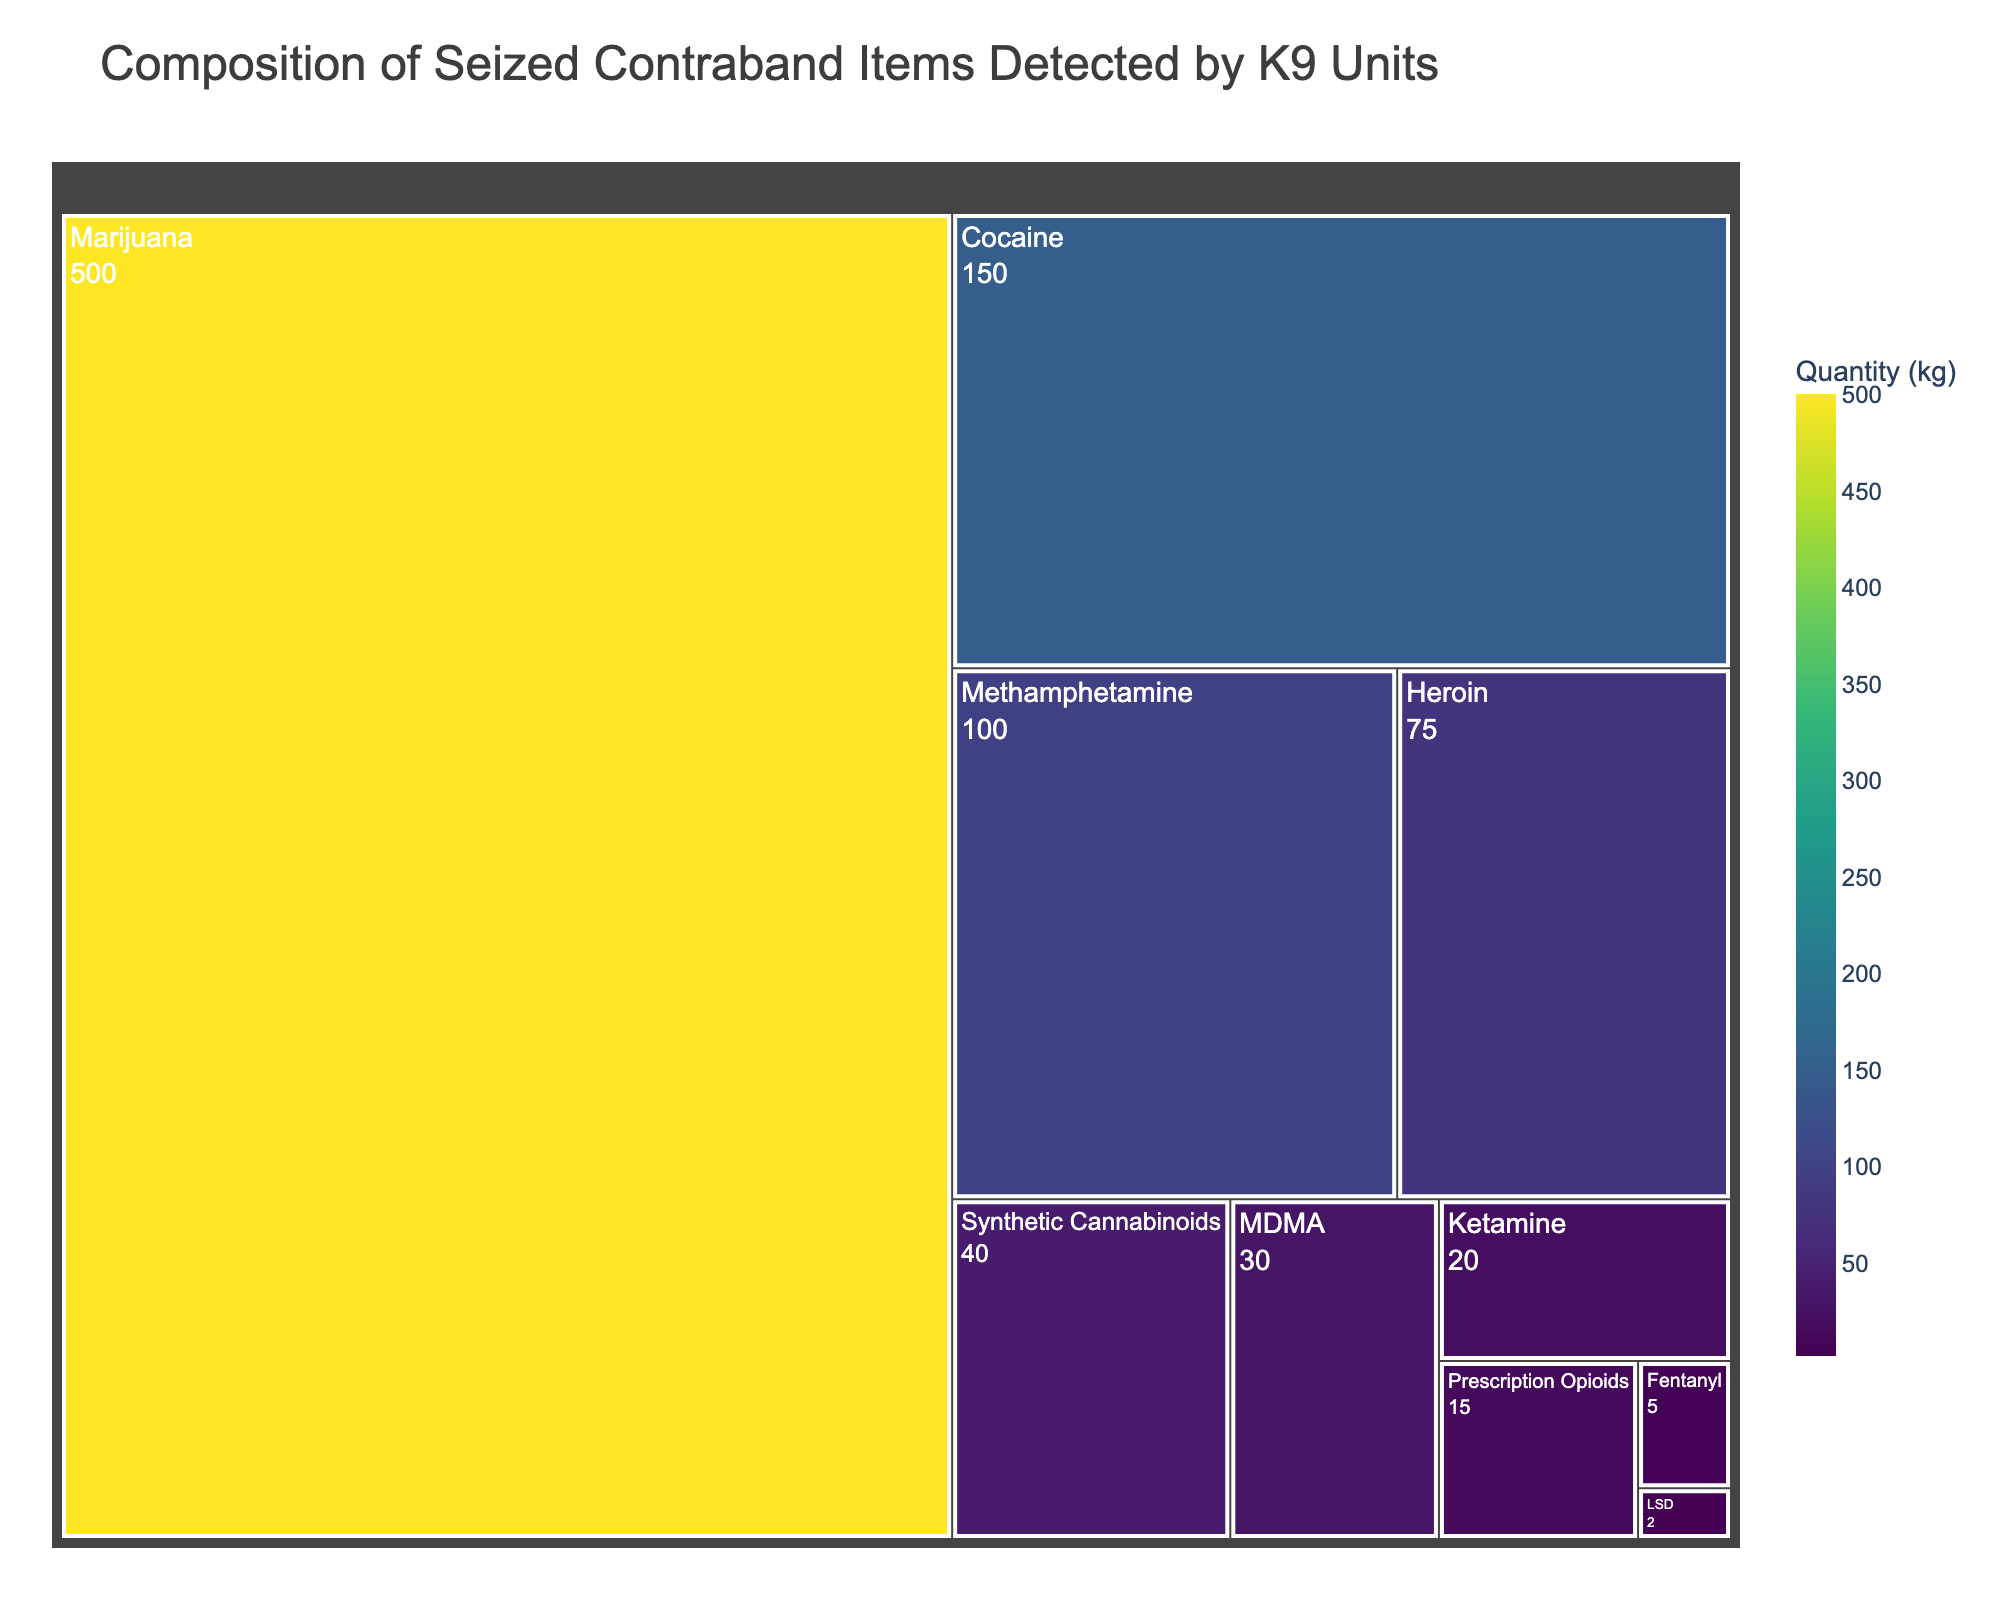Which drug type has the largest quantity of seized contraband? The largest section in the treemap represents marijuana. We can see it's the most significant area, which indicates the highest quantity.
Answer: Marijuana What is the combined quantity of Cocaine and Methamphetamine? The quantity of Cocaine is 150 kg and Methamphetamine is 100 kg. Adding these gives: 150 kg + 100 kg = 250 kg.
Answer: 250 kg How many different drug types are represented in the treemap? Each distinct section in the treemap represents a different drug type. Counting them, we see: Cocaine, Heroin, Methamphetamine, Marijuana, MDMA, Fentanyl, Ketamine, LSD, Synthetic Cannabinoids, Prescription Opioids, totaling 10 drug types.
Answer: 10 Which drug type has the smallest quantity of seized contraband? The smallest section in the treemap corresponds to LSD, highlighted by both the area and the quantity value of 2 kg.
Answer: LSD By how much does the quantity of Marijuana exceed the quantity of Heroin? The quantity of Marijuana is 500 kg, and the quantity of Heroin is 75 kg. The difference is 500 kg - 75 kg = 425 kg.
Answer: 425 kg What is the average quantity of all seized contraband items? First, sum all the quantities: 150 + 75 + 100 + 500 + 30 + 5 + 20 + 2 + 40 + 15 = 937 kg. Then divide by the number of drug types (10): 937 kg / 10 = 93.7 kg.
Answer: 93.7 kg Which drug type has a quantity closer to the average quantity of all items? The average quantity is 93.7 kg. Comparing each value, Synthetic Cannabinoids (40 kg), Prescription Opioids (15 kg), Methamphetamine (100 kg), and Cocaine (150 kg), Methamphetamine's 100 kg is closest to 93.7 kg.
Answer: Methamphetamine How does the quantity of MDMA compare to that of Ketamine? The quantity of MDMA is 30 kg, whereas Ketamine is 20 kg. Therefore, MDMA exceeds Ketamine by 10 kg (30 kg - 20 kg).
Answer: MDMA exceeds Ketamine by 10 kg What percentage of the total contraband does Marijuana represent? Total quantity is 937 kg. Marijuana's quantity is 500 kg. The percentage is (500 / 937) * 100 ≈ 53.36%.
Answer: ≈ 53.36% How much more of Cocaine is there compared to Prescription Opioids? Cocaine has 150 kg while Prescription Opioids have 15 kg. The difference is 150 kg - 15 kg = 135 kg.
Answer: 135 kg 